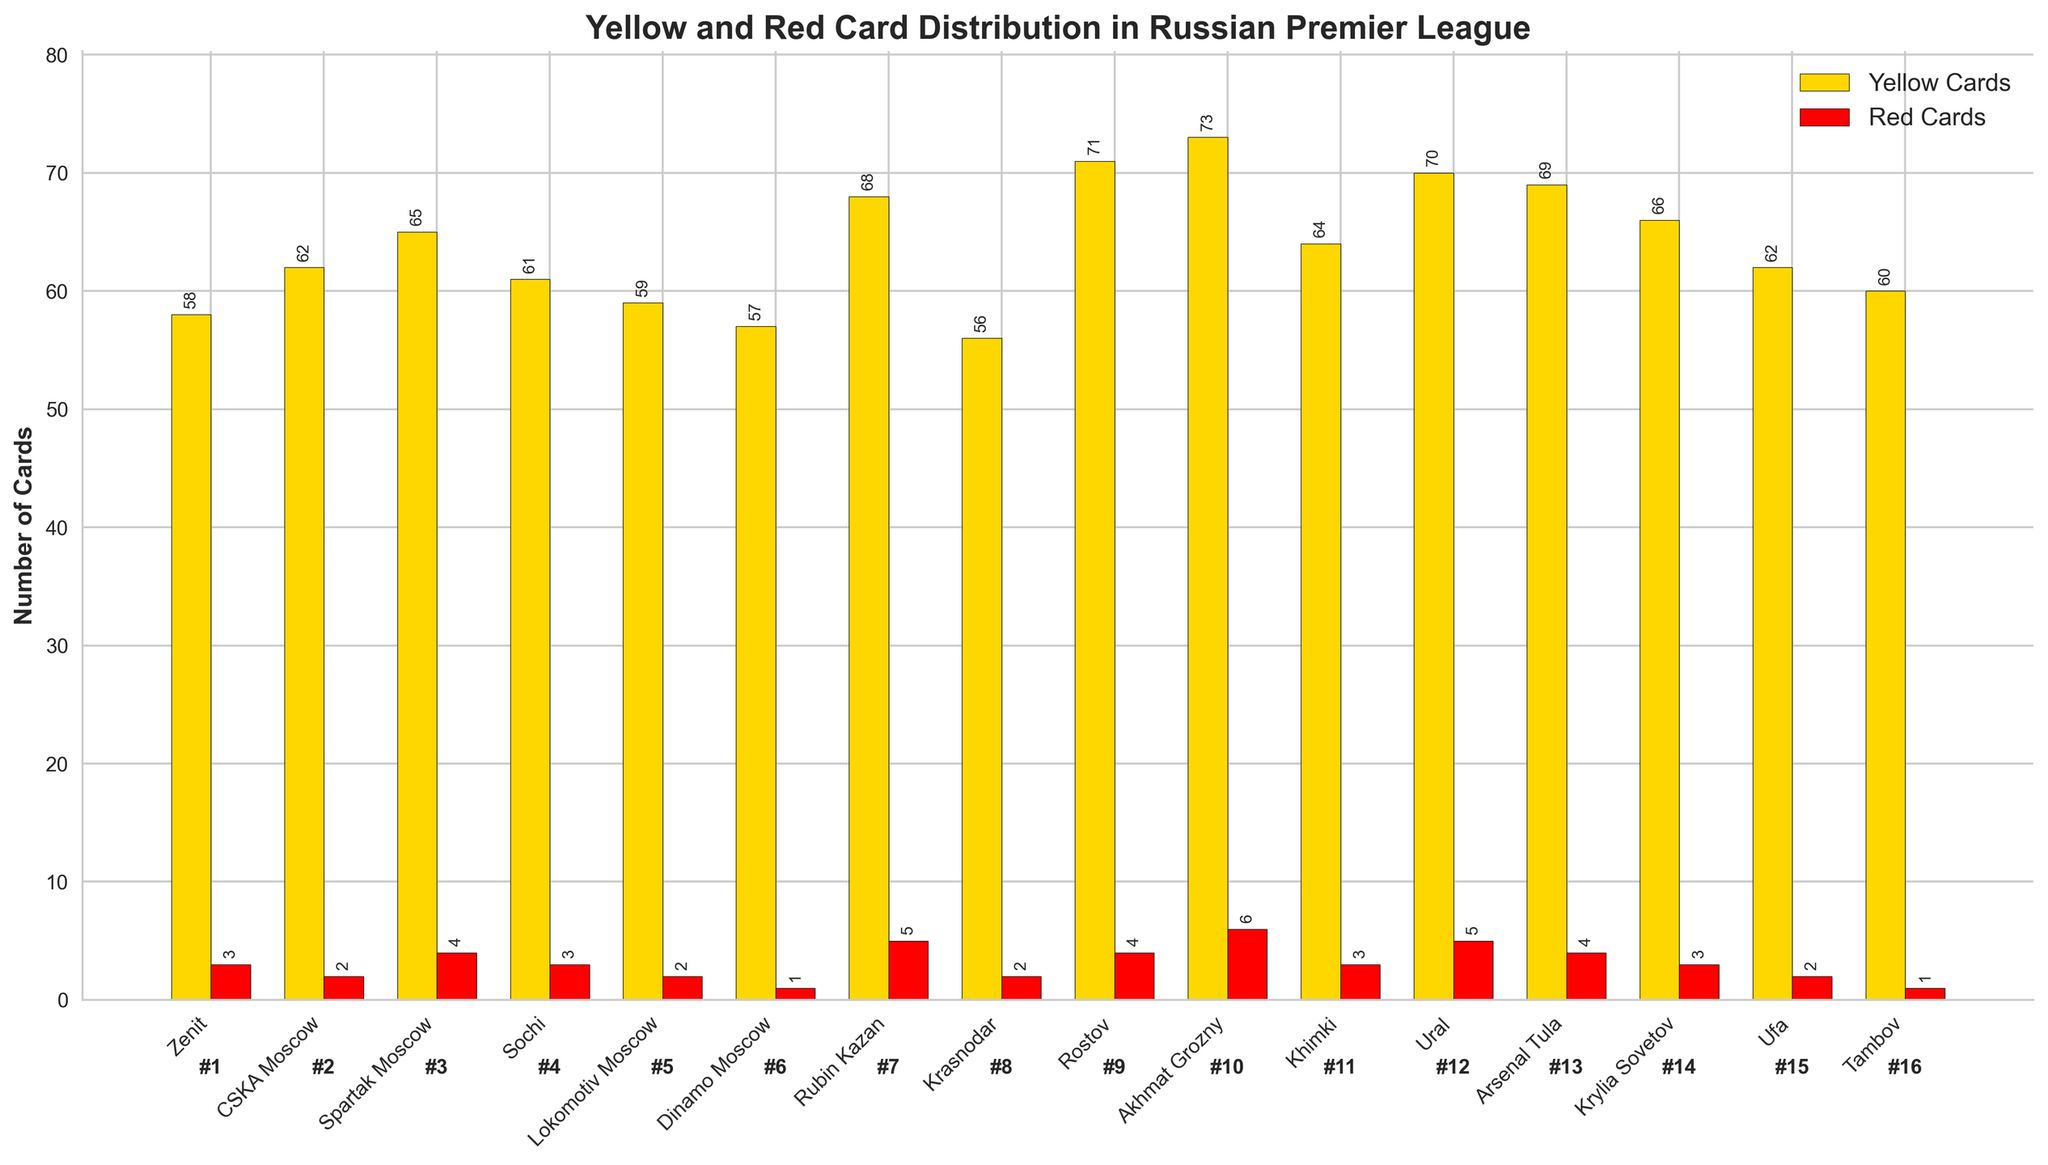Which team had the most yellow cards? Observing the heights of the gold bars, Akhmat Grozny has the highest yellow card count.
Answer: Akhmat Grozny Which team received the least number of red cards? By looking at the heights of the red bars, Dinamo Moscow and Tambov each have only one red card.
Answer: Dinamo Moscow or Tambov How many more yellow cards did Rubin Kazan receive compared to Dinamo Moscow? Rubin Kazan received 68 yellow cards, and Dinamo Moscow received 57 yellow cards. The difference is 68 - 57.
Answer: 11 Add the total number of cards (yellow and red) for Lokomotiv Moscow and compare it to the total for Krasnodar. Lokomotiv Moscow: 59 yellow + 2 red = 61. Krasnodar: 56 yellow + 2 red = 58. Lokomotiv Moscow has 61 - 58 more cards than Krasnodar.
Answer: 3 Which position did the team with the highest number of red cards finish? The tallest red bar belongs to Akhmat Grozny. Their position is shown as 10th below the bar.
Answer: 10th How many teams received more than 60 yellow cards? Teams with more than 60 yellow cards are: CSKA Moscow, Spartak Moscow, Sochi, Rubin Kazan, Rostov, Khimki, Ural, Arsenal Tula, Krylia Sovetov, Ufa. There are 10 such teams.
Answer: 10 teams What's the combined total of yellow and red cards for Zenit and CSKA Moscow? Zenit: 58 yellow + 3 red = 61. CSKA Moscow: 62 yellow + 2 red = 64. Total combined = 61 + 64.
Answer: 125 Which team finished 11th, and how many cards in total did they receive? The 11th place team, as indicated below the bar, is Khimki. They received 64 yellow + 3 red = 67 cards.
Answer: Khimki, 67 cards Do any teams with a position lower than 14th have fewer yellow cards than Tambov? The teams lower than 14th are Ufa (62 yellow) and Tambov (60 yellow). Ufa does not have fewer yellow cards than Tambov.
Answer: No Compare the total number of cards for the top 2 teams. Which team has fewer, and by how many? Zenit: 58 yellow + 3 red = 61. CSKA Moscow: 62 yellow + 2 red = 64. Zenit has 64 - 61 fewer cards than CSKA Moscow.
Answer: Zenit, 3 fewer 